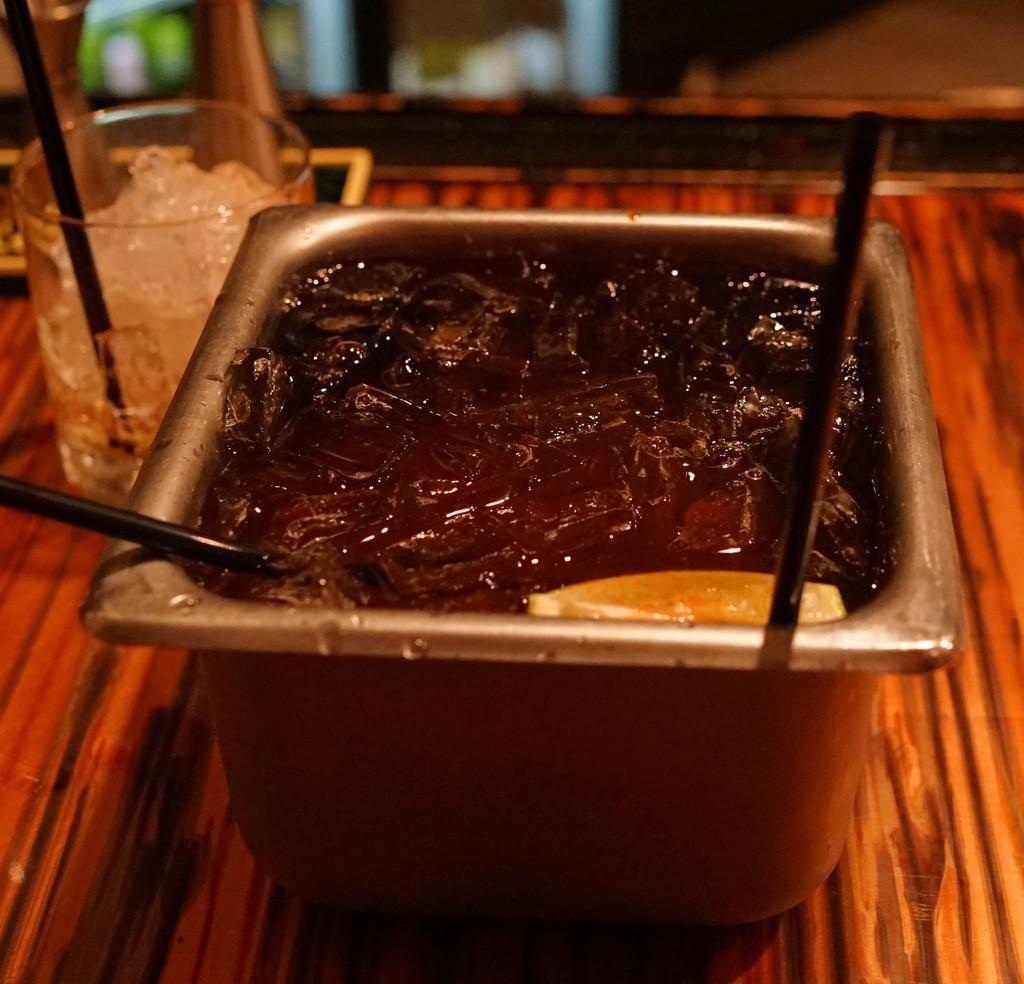Please provide a concise description of this image. In this image, we can see a table, on that table there is a container, in that there is ice and water, we can see a glass and there is ice in the glass. 